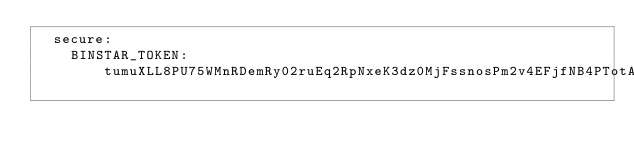Convert code to text. <code><loc_0><loc_0><loc_500><loc_500><_YAML_>  secure:
    BINSTAR_TOKEN: tumuXLL8PU75WMnRDemRy02ruEq2RpNxeK3dz0MjFssnosPm2v4EFjfNB4PTotA1
</code> 